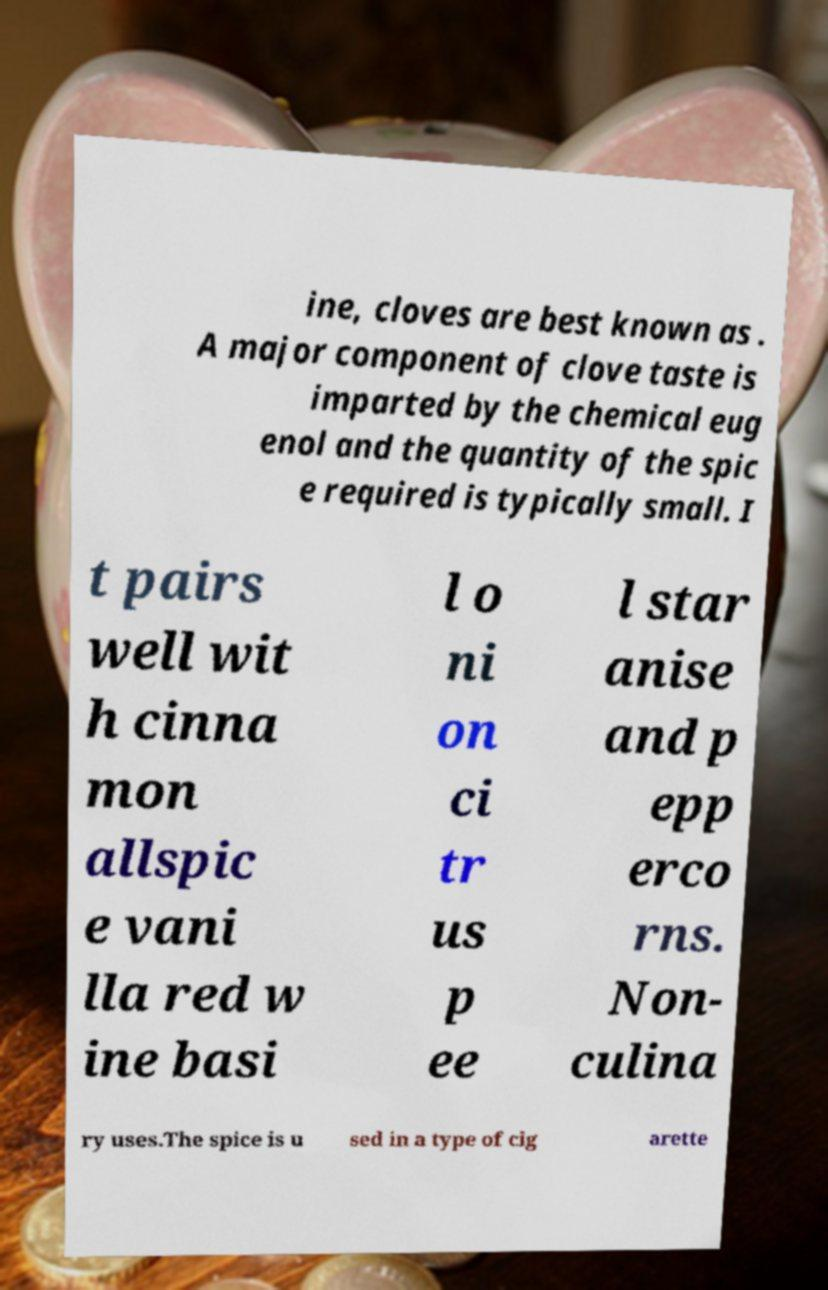I need the written content from this picture converted into text. Can you do that? ine, cloves are best known as . A major component of clove taste is imparted by the chemical eug enol and the quantity of the spic e required is typically small. I t pairs well wit h cinna mon allspic e vani lla red w ine basi l o ni on ci tr us p ee l star anise and p epp erco rns. Non- culina ry uses.The spice is u sed in a type of cig arette 